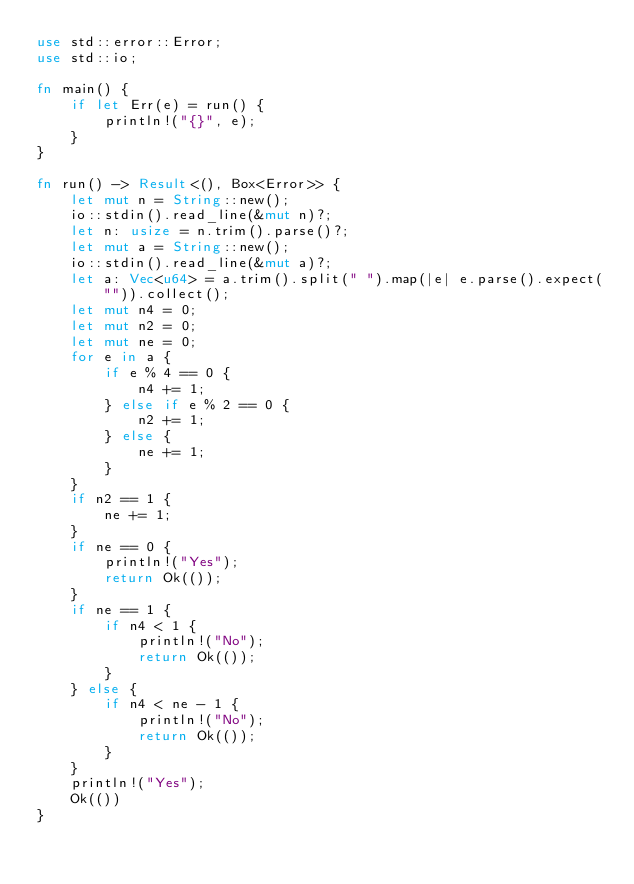<code> <loc_0><loc_0><loc_500><loc_500><_Rust_>use std::error::Error;
use std::io;

fn main() {
    if let Err(e) = run() {
        println!("{}", e);
    }
}

fn run() -> Result<(), Box<Error>> {
    let mut n = String::new();
    io::stdin().read_line(&mut n)?;
    let n: usize = n.trim().parse()?;
    let mut a = String::new();
    io::stdin().read_line(&mut a)?;
    let a: Vec<u64> = a.trim().split(" ").map(|e| e.parse().expect("")).collect();
    let mut n4 = 0;
    let mut n2 = 0;
    let mut ne = 0;
    for e in a {
        if e % 4 == 0 {
            n4 += 1;
        } else if e % 2 == 0 {
            n2 += 1;
        } else {
            ne += 1;
        }
    }
    if n2 == 1 {
        ne += 1;
    }
    if ne == 0 {
        println!("Yes");
        return Ok(());
    }
    if ne == 1 {
        if n4 < 1 {
            println!("No");
            return Ok(());
        }
    } else {
        if n4 < ne - 1 {
            println!("No");
            return Ok(());
        }
    }
    println!("Yes");
    Ok(())
}
</code> 